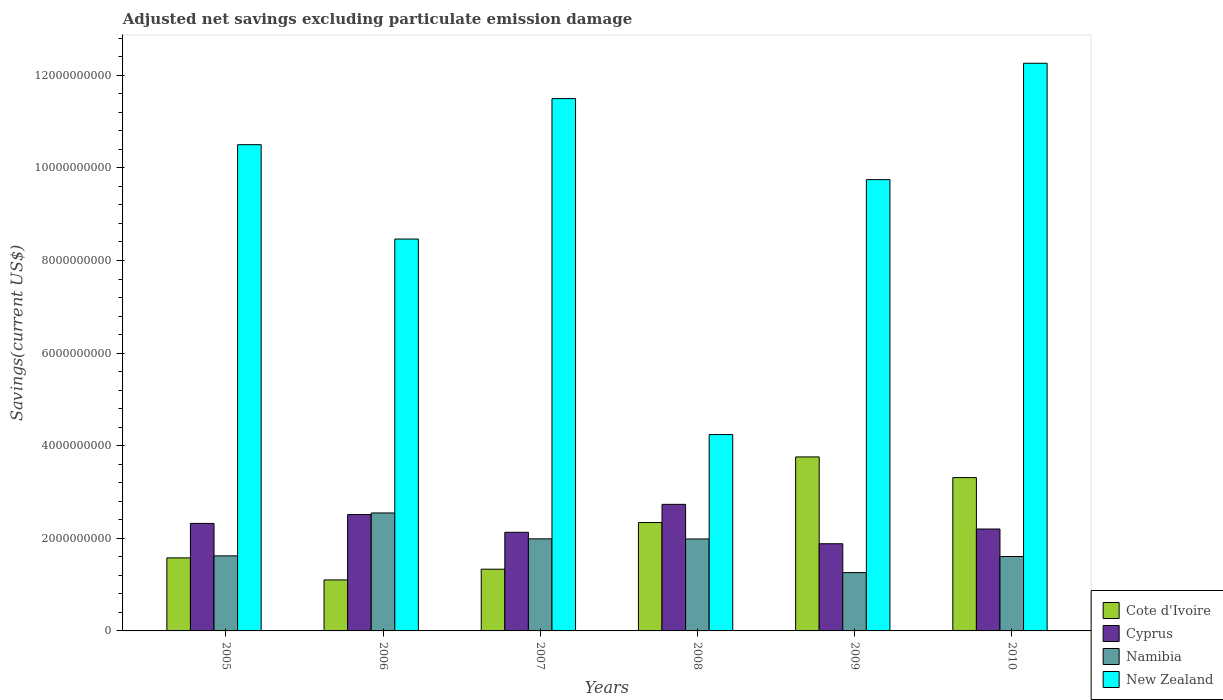Are the number of bars per tick equal to the number of legend labels?
Offer a very short reply. Yes. Are the number of bars on each tick of the X-axis equal?
Ensure brevity in your answer.  Yes. How many bars are there on the 6th tick from the left?
Provide a succinct answer. 4. How many bars are there on the 2nd tick from the right?
Your response must be concise. 4. What is the adjusted net savings in Namibia in 2009?
Make the answer very short. 1.26e+09. Across all years, what is the maximum adjusted net savings in Cyprus?
Keep it short and to the point. 2.73e+09. Across all years, what is the minimum adjusted net savings in Namibia?
Your answer should be compact. 1.26e+09. In which year was the adjusted net savings in Cote d'Ivoire maximum?
Provide a succinct answer. 2009. What is the total adjusted net savings in Cyprus in the graph?
Provide a succinct answer. 1.38e+1. What is the difference between the adjusted net savings in Cote d'Ivoire in 2005 and that in 2006?
Your answer should be compact. 4.76e+08. What is the difference between the adjusted net savings in New Zealand in 2008 and the adjusted net savings in Namibia in 2005?
Give a very brief answer. 2.62e+09. What is the average adjusted net savings in New Zealand per year?
Provide a short and direct response. 9.45e+09. In the year 2006, what is the difference between the adjusted net savings in Cote d'Ivoire and adjusted net savings in Cyprus?
Give a very brief answer. -1.41e+09. What is the ratio of the adjusted net savings in New Zealand in 2005 to that in 2006?
Your answer should be very brief. 1.24. Is the adjusted net savings in Cyprus in 2007 less than that in 2008?
Give a very brief answer. Yes. Is the difference between the adjusted net savings in Cote d'Ivoire in 2006 and 2009 greater than the difference between the adjusted net savings in Cyprus in 2006 and 2009?
Give a very brief answer. No. What is the difference between the highest and the second highest adjusted net savings in Cyprus?
Keep it short and to the point. 2.20e+08. What is the difference between the highest and the lowest adjusted net savings in New Zealand?
Your answer should be compact. 8.02e+09. Is the sum of the adjusted net savings in Cote d'Ivoire in 2009 and 2010 greater than the maximum adjusted net savings in Cyprus across all years?
Give a very brief answer. Yes. What does the 3rd bar from the left in 2010 represents?
Give a very brief answer. Namibia. What does the 1st bar from the right in 2008 represents?
Offer a very short reply. New Zealand. Is it the case that in every year, the sum of the adjusted net savings in Namibia and adjusted net savings in Cote d'Ivoire is greater than the adjusted net savings in Cyprus?
Offer a terse response. Yes. How many bars are there?
Keep it short and to the point. 24. Does the graph contain grids?
Give a very brief answer. No. Where does the legend appear in the graph?
Your response must be concise. Bottom right. What is the title of the graph?
Make the answer very short. Adjusted net savings excluding particulate emission damage. What is the label or title of the Y-axis?
Your answer should be compact. Savings(current US$). What is the Savings(current US$) of Cote d'Ivoire in 2005?
Offer a very short reply. 1.58e+09. What is the Savings(current US$) of Cyprus in 2005?
Offer a very short reply. 2.32e+09. What is the Savings(current US$) in Namibia in 2005?
Offer a very short reply. 1.62e+09. What is the Savings(current US$) of New Zealand in 2005?
Your response must be concise. 1.05e+1. What is the Savings(current US$) in Cote d'Ivoire in 2006?
Keep it short and to the point. 1.10e+09. What is the Savings(current US$) of Cyprus in 2006?
Ensure brevity in your answer.  2.51e+09. What is the Savings(current US$) in Namibia in 2006?
Your response must be concise. 2.55e+09. What is the Savings(current US$) in New Zealand in 2006?
Your response must be concise. 8.46e+09. What is the Savings(current US$) in Cote d'Ivoire in 2007?
Give a very brief answer. 1.33e+09. What is the Savings(current US$) in Cyprus in 2007?
Keep it short and to the point. 2.13e+09. What is the Savings(current US$) of Namibia in 2007?
Offer a terse response. 1.99e+09. What is the Savings(current US$) in New Zealand in 2007?
Your answer should be very brief. 1.15e+1. What is the Savings(current US$) of Cote d'Ivoire in 2008?
Give a very brief answer. 2.34e+09. What is the Savings(current US$) in Cyprus in 2008?
Keep it short and to the point. 2.73e+09. What is the Savings(current US$) in Namibia in 2008?
Provide a short and direct response. 1.99e+09. What is the Savings(current US$) in New Zealand in 2008?
Ensure brevity in your answer.  4.24e+09. What is the Savings(current US$) in Cote d'Ivoire in 2009?
Give a very brief answer. 3.76e+09. What is the Savings(current US$) in Cyprus in 2009?
Provide a succinct answer. 1.88e+09. What is the Savings(current US$) of Namibia in 2009?
Offer a terse response. 1.26e+09. What is the Savings(current US$) of New Zealand in 2009?
Provide a succinct answer. 9.75e+09. What is the Savings(current US$) in Cote d'Ivoire in 2010?
Provide a succinct answer. 3.31e+09. What is the Savings(current US$) in Cyprus in 2010?
Keep it short and to the point. 2.20e+09. What is the Savings(current US$) of Namibia in 2010?
Your response must be concise. 1.61e+09. What is the Savings(current US$) in New Zealand in 2010?
Your answer should be very brief. 1.23e+1. Across all years, what is the maximum Savings(current US$) in Cote d'Ivoire?
Provide a short and direct response. 3.76e+09. Across all years, what is the maximum Savings(current US$) of Cyprus?
Ensure brevity in your answer.  2.73e+09. Across all years, what is the maximum Savings(current US$) of Namibia?
Your answer should be very brief. 2.55e+09. Across all years, what is the maximum Savings(current US$) of New Zealand?
Give a very brief answer. 1.23e+1. Across all years, what is the minimum Savings(current US$) of Cote d'Ivoire?
Your answer should be very brief. 1.10e+09. Across all years, what is the minimum Savings(current US$) of Cyprus?
Your response must be concise. 1.88e+09. Across all years, what is the minimum Savings(current US$) in Namibia?
Your response must be concise. 1.26e+09. Across all years, what is the minimum Savings(current US$) in New Zealand?
Ensure brevity in your answer.  4.24e+09. What is the total Savings(current US$) of Cote d'Ivoire in the graph?
Your answer should be very brief. 1.34e+1. What is the total Savings(current US$) in Cyprus in the graph?
Offer a very short reply. 1.38e+1. What is the total Savings(current US$) of Namibia in the graph?
Keep it short and to the point. 1.10e+1. What is the total Savings(current US$) in New Zealand in the graph?
Make the answer very short. 5.67e+1. What is the difference between the Savings(current US$) in Cote d'Ivoire in 2005 and that in 2006?
Provide a succinct answer. 4.76e+08. What is the difference between the Savings(current US$) of Cyprus in 2005 and that in 2006?
Your response must be concise. -1.91e+08. What is the difference between the Savings(current US$) in Namibia in 2005 and that in 2006?
Your answer should be compact. -9.27e+08. What is the difference between the Savings(current US$) in New Zealand in 2005 and that in 2006?
Make the answer very short. 2.04e+09. What is the difference between the Savings(current US$) of Cote d'Ivoire in 2005 and that in 2007?
Ensure brevity in your answer.  2.44e+08. What is the difference between the Savings(current US$) of Cyprus in 2005 and that in 2007?
Provide a short and direct response. 1.92e+08. What is the difference between the Savings(current US$) in Namibia in 2005 and that in 2007?
Ensure brevity in your answer.  -3.68e+08. What is the difference between the Savings(current US$) of New Zealand in 2005 and that in 2007?
Make the answer very short. -9.95e+08. What is the difference between the Savings(current US$) of Cote d'Ivoire in 2005 and that in 2008?
Provide a succinct answer. -7.64e+08. What is the difference between the Savings(current US$) of Cyprus in 2005 and that in 2008?
Offer a terse response. -4.12e+08. What is the difference between the Savings(current US$) of Namibia in 2005 and that in 2008?
Provide a short and direct response. -3.65e+08. What is the difference between the Savings(current US$) of New Zealand in 2005 and that in 2008?
Ensure brevity in your answer.  6.26e+09. What is the difference between the Savings(current US$) in Cote d'Ivoire in 2005 and that in 2009?
Provide a succinct answer. -2.18e+09. What is the difference between the Savings(current US$) of Cyprus in 2005 and that in 2009?
Your response must be concise. 4.39e+08. What is the difference between the Savings(current US$) in Namibia in 2005 and that in 2009?
Provide a short and direct response. 3.61e+08. What is the difference between the Savings(current US$) of New Zealand in 2005 and that in 2009?
Offer a very short reply. 7.55e+08. What is the difference between the Savings(current US$) in Cote d'Ivoire in 2005 and that in 2010?
Provide a short and direct response. -1.73e+09. What is the difference between the Savings(current US$) of Cyprus in 2005 and that in 2010?
Your response must be concise. 1.21e+08. What is the difference between the Savings(current US$) in Namibia in 2005 and that in 2010?
Provide a short and direct response. 1.40e+07. What is the difference between the Savings(current US$) of New Zealand in 2005 and that in 2010?
Your answer should be very brief. -1.76e+09. What is the difference between the Savings(current US$) in Cote d'Ivoire in 2006 and that in 2007?
Keep it short and to the point. -2.32e+08. What is the difference between the Savings(current US$) in Cyprus in 2006 and that in 2007?
Your answer should be compact. 3.83e+08. What is the difference between the Savings(current US$) in Namibia in 2006 and that in 2007?
Provide a short and direct response. 5.59e+08. What is the difference between the Savings(current US$) of New Zealand in 2006 and that in 2007?
Make the answer very short. -3.03e+09. What is the difference between the Savings(current US$) of Cote d'Ivoire in 2006 and that in 2008?
Provide a succinct answer. -1.24e+09. What is the difference between the Savings(current US$) of Cyprus in 2006 and that in 2008?
Ensure brevity in your answer.  -2.20e+08. What is the difference between the Savings(current US$) in Namibia in 2006 and that in 2008?
Offer a terse response. 5.61e+08. What is the difference between the Savings(current US$) of New Zealand in 2006 and that in 2008?
Offer a very short reply. 4.22e+09. What is the difference between the Savings(current US$) of Cote d'Ivoire in 2006 and that in 2009?
Ensure brevity in your answer.  -2.66e+09. What is the difference between the Savings(current US$) of Cyprus in 2006 and that in 2009?
Make the answer very short. 6.30e+08. What is the difference between the Savings(current US$) of Namibia in 2006 and that in 2009?
Offer a very short reply. 1.29e+09. What is the difference between the Savings(current US$) of New Zealand in 2006 and that in 2009?
Ensure brevity in your answer.  -1.28e+09. What is the difference between the Savings(current US$) in Cote d'Ivoire in 2006 and that in 2010?
Offer a terse response. -2.21e+09. What is the difference between the Savings(current US$) of Cyprus in 2006 and that in 2010?
Make the answer very short. 3.12e+08. What is the difference between the Savings(current US$) of Namibia in 2006 and that in 2010?
Your answer should be very brief. 9.41e+08. What is the difference between the Savings(current US$) of New Zealand in 2006 and that in 2010?
Your response must be concise. -3.80e+09. What is the difference between the Savings(current US$) of Cote d'Ivoire in 2007 and that in 2008?
Ensure brevity in your answer.  -1.01e+09. What is the difference between the Savings(current US$) in Cyprus in 2007 and that in 2008?
Ensure brevity in your answer.  -6.04e+08. What is the difference between the Savings(current US$) of Namibia in 2007 and that in 2008?
Provide a succinct answer. 2.53e+06. What is the difference between the Savings(current US$) in New Zealand in 2007 and that in 2008?
Offer a very short reply. 7.26e+09. What is the difference between the Savings(current US$) of Cote d'Ivoire in 2007 and that in 2009?
Ensure brevity in your answer.  -2.42e+09. What is the difference between the Savings(current US$) of Cyprus in 2007 and that in 2009?
Keep it short and to the point. 2.47e+08. What is the difference between the Savings(current US$) in Namibia in 2007 and that in 2009?
Provide a succinct answer. 7.29e+08. What is the difference between the Savings(current US$) of New Zealand in 2007 and that in 2009?
Make the answer very short. 1.75e+09. What is the difference between the Savings(current US$) in Cote d'Ivoire in 2007 and that in 2010?
Provide a short and direct response. -1.98e+09. What is the difference between the Savings(current US$) of Cyprus in 2007 and that in 2010?
Provide a succinct answer. -7.11e+07. What is the difference between the Savings(current US$) of Namibia in 2007 and that in 2010?
Your response must be concise. 3.82e+08. What is the difference between the Savings(current US$) of New Zealand in 2007 and that in 2010?
Provide a succinct answer. -7.63e+08. What is the difference between the Savings(current US$) in Cote d'Ivoire in 2008 and that in 2009?
Your answer should be very brief. -1.42e+09. What is the difference between the Savings(current US$) in Cyprus in 2008 and that in 2009?
Provide a short and direct response. 8.51e+08. What is the difference between the Savings(current US$) of Namibia in 2008 and that in 2009?
Offer a terse response. 7.27e+08. What is the difference between the Savings(current US$) in New Zealand in 2008 and that in 2009?
Provide a short and direct response. -5.51e+09. What is the difference between the Savings(current US$) of Cote d'Ivoire in 2008 and that in 2010?
Offer a very short reply. -9.71e+08. What is the difference between the Savings(current US$) in Cyprus in 2008 and that in 2010?
Give a very brief answer. 5.33e+08. What is the difference between the Savings(current US$) in Namibia in 2008 and that in 2010?
Provide a short and direct response. 3.79e+08. What is the difference between the Savings(current US$) of New Zealand in 2008 and that in 2010?
Offer a very short reply. -8.02e+09. What is the difference between the Savings(current US$) in Cote d'Ivoire in 2009 and that in 2010?
Ensure brevity in your answer.  4.46e+08. What is the difference between the Savings(current US$) of Cyprus in 2009 and that in 2010?
Keep it short and to the point. -3.18e+08. What is the difference between the Savings(current US$) of Namibia in 2009 and that in 2010?
Your answer should be very brief. -3.47e+08. What is the difference between the Savings(current US$) in New Zealand in 2009 and that in 2010?
Provide a succinct answer. -2.51e+09. What is the difference between the Savings(current US$) of Cote d'Ivoire in 2005 and the Savings(current US$) of Cyprus in 2006?
Make the answer very short. -9.36e+08. What is the difference between the Savings(current US$) in Cote d'Ivoire in 2005 and the Savings(current US$) in Namibia in 2006?
Keep it short and to the point. -9.70e+08. What is the difference between the Savings(current US$) in Cote d'Ivoire in 2005 and the Savings(current US$) in New Zealand in 2006?
Give a very brief answer. -6.89e+09. What is the difference between the Savings(current US$) in Cyprus in 2005 and the Savings(current US$) in Namibia in 2006?
Your answer should be very brief. -2.26e+08. What is the difference between the Savings(current US$) in Cyprus in 2005 and the Savings(current US$) in New Zealand in 2006?
Provide a succinct answer. -6.14e+09. What is the difference between the Savings(current US$) in Namibia in 2005 and the Savings(current US$) in New Zealand in 2006?
Give a very brief answer. -6.84e+09. What is the difference between the Savings(current US$) of Cote d'Ivoire in 2005 and the Savings(current US$) of Cyprus in 2007?
Offer a terse response. -5.53e+08. What is the difference between the Savings(current US$) in Cote d'Ivoire in 2005 and the Savings(current US$) in Namibia in 2007?
Provide a short and direct response. -4.11e+08. What is the difference between the Savings(current US$) of Cote d'Ivoire in 2005 and the Savings(current US$) of New Zealand in 2007?
Provide a short and direct response. -9.92e+09. What is the difference between the Savings(current US$) in Cyprus in 2005 and the Savings(current US$) in Namibia in 2007?
Provide a succinct answer. 3.33e+08. What is the difference between the Savings(current US$) of Cyprus in 2005 and the Savings(current US$) of New Zealand in 2007?
Provide a succinct answer. -9.18e+09. What is the difference between the Savings(current US$) of Namibia in 2005 and the Savings(current US$) of New Zealand in 2007?
Offer a very short reply. -9.88e+09. What is the difference between the Savings(current US$) of Cote d'Ivoire in 2005 and the Savings(current US$) of Cyprus in 2008?
Provide a short and direct response. -1.16e+09. What is the difference between the Savings(current US$) in Cote d'Ivoire in 2005 and the Savings(current US$) in Namibia in 2008?
Give a very brief answer. -4.09e+08. What is the difference between the Savings(current US$) of Cote d'Ivoire in 2005 and the Savings(current US$) of New Zealand in 2008?
Provide a short and direct response. -2.66e+09. What is the difference between the Savings(current US$) of Cyprus in 2005 and the Savings(current US$) of Namibia in 2008?
Your answer should be compact. 3.36e+08. What is the difference between the Savings(current US$) in Cyprus in 2005 and the Savings(current US$) in New Zealand in 2008?
Offer a very short reply. -1.92e+09. What is the difference between the Savings(current US$) of Namibia in 2005 and the Savings(current US$) of New Zealand in 2008?
Ensure brevity in your answer.  -2.62e+09. What is the difference between the Savings(current US$) of Cote d'Ivoire in 2005 and the Savings(current US$) of Cyprus in 2009?
Offer a very short reply. -3.06e+08. What is the difference between the Savings(current US$) of Cote d'Ivoire in 2005 and the Savings(current US$) of Namibia in 2009?
Your response must be concise. 3.18e+08. What is the difference between the Savings(current US$) of Cote d'Ivoire in 2005 and the Savings(current US$) of New Zealand in 2009?
Give a very brief answer. -8.17e+09. What is the difference between the Savings(current US$) in Cyprus in 2005 and the Savings(current US$) in Namibia in 2009?
Your response must be concise. 1.06e+09. What is the difference between the Savings(current US$) in Cyprus in 2005 and the Savings(current US$) in New Zealand in 2009?
Make the answer very short. -7.43e+09. What is the difference between the Savings(current US$) of Namibia in 2005 and the Savings(current US$) of New Zealand in 2009?
Ensure brevity in your answer.  -8.13e+09. What is the difference between the Savings(current US$) of Cote d'Ivoire in 2005 and the Savings(current US$) of Cyprus in 2010?
Provide a short and direct response. -6.24e+08. What is the difference between the Savings(current US$) of Cote d'Ivoire in 2005 and the Savings(current US$) of Namibia in 2010?
Provide a succinct answer. -2.97e+07. What is the difference between the Savings(current US$) in Cote d'Ivoire in 2005 and the Savings(current US$) in New Zealand in 2010?
Offer a very short reply. -1.07e+1. What is the difference between the Savings(current US$) in Cyprus in 2005 and the Savings(current US$) in Namibia in 2010?
Your response must be concise. 7.15e+08. What is the difference between the Savings(current US$) in Cyprus in 2005 and the Savings(current US$) in New Zealand in 2010?
Your response must be concise. -9.94e+09. What is the difference between the Savings(current US$) in Namibia in 2005 and the Savings(current US$) in New Zealand in 2010?
Provide a short and direct response. -1.06e+1. What is the difference between the Savings(current US$) in Cote d'Ivoire in 2006 and the Savings(current US$) in Cyprus in 2007?
Give a very brief answer. -1.03e+09. What is the difference between the Savings(current US$) in Cote d'Ivoire in 2006 and the Savings(current US$) in Namibia in 2007?
Offer a terse response. -8.87e+08. What is the difference between the Savings(current US$) of Cote d'Ivoire in 2006 and the Savings(current US$) of New Zealand in 2007?
Give a very brief answer. -1.04e+1. What is the difference between the Savings(current US$) of Cyprus in 2006 and the Savings(current US$) of Namibia in 2007?
Provide a succinct answer. 5.25e+08. What is the difference between the Savings(current US$) in Cyprus in 2006 and the Savings(current US$) in New Zealand in 2007?
Ensure brevity in your answer.  -8.98e+09. What is the difference between the Savings(current US$) of Namibia in 2006 and the Savings(current US$) of New Zealand in 2007?
Provide a succinct answer. -8.95e+09. What is the difference between the Savings(current US$) of Cote d'Ivoire in 2006 and the Savings(current US$) of Cyprus in 2008?
Offer a very short reply. -1.63e+09. What is the difference between the Savings(current US$) in Cote d'Ivoire in 2006 and the Savings(current US$) in Namibia in 2008?
Ensure brevity in your answer.  -8.85e+08. What is the difference between the Savings(current US$) of Cote d'Ivoire in 2006 and the Savings(current US$) of New Zealand in 2008?
Provide a short and direct response. -3.14e+09. What is the difference between the Savings(current US$) in Cyprus in 2006 and the Savings(current US$) in Namibia in 2008?
Offer a very short reply. 5.27e+08. What is the difference between the Savings(current US$) of Cyprus in 2006 and the Savings(current US$) of New Zealand in 2008?
Offer a very short reply. -1.73e+09. What is the difference between the Savings(current US$) in Namibia in 2006 and the Savings(current US$) in New Zealand in 2008?
Keep it short and to the point. -1.69e+09. What is the difference between the Savings(current US$) in Cote d'Ivoire in 2006 and the Savings(current US$) in Cyprus in 2009?
Provide a succinct answer. -7.81e+08. What is the difference between the Savings(current US$) in Cote d'Ivoire in 2006 and the Savings(current US$) in Namibia in 2009?
Make the answer very short. -1.58e+08. What is the difference between the Savings(current US$) of Cote d'Ivoire in 2006 and the Savings(current US$) of New Zealand in 2009?
Ensure brevity in your answer.  -8.65e+09. What is the difference between the Savings(current US$) in Cyprus in 2006 and the Savings(current US$) in Namibia in 2009?
Make the answer very short. 1.25e+09. What is the difference between the Savings(current US$) of Cyprus in 2006 and the Savings(current US$) of New Zealand in 2009?
Offer a very short reply. -7.23e+09. What is the difference between the Savings(current US$) in Namibia in 2006 and the Savings(current US$) in New Zealand in 2009?
Keep it short and to the point. -7.20e+09. What is the difference between the Savings(current US$) in Cote d'Ivoire in 2006 and the Savings(current US$) in Cyprus in 2010?
Offer a very short reply. -1.10e+09. What is the difference between the Savings(current US$) in Cote d'Ivoire in 2006 and the Savings(current US$) in Namibia in 2010?
Keep it short and to the point. -5.05e+08. What is the difference between the Savings(current US$) in Cote d'Ivoire in 2006 and the Savings(current US$) in New Zealand in 2010?
Provide a short and direct response. -1.12e+1. What is the difference between the Savings(current US$) in Cyprus in 2006 and the Savings(current US$) in Namibia in 2010?
Offer a terse response. 9.06e+08. What is the difference between the Savings(current US$) in Cyprus in 2006 and the Savings(current US$) in New Zealand in 2010?
Give a very brief answer. -9.75e+09. What is the difference between the Savings(current US$) in Namibia in 2006 and the Savings(current US$) in New Zealand in 2010?
Your answer should be very brief. -9.71e+09. What is the difference between the Savings(current US$) of Cote d'Ivoire in 2007 and the Savings(current US$) of Cyprus in 2008?
Ensure brevity in your answer.  -1.40e+09. What is the difference between the Savings(current US$) in Cote d'Ivoire in 2007 and the Savings(current US$) in Namibia in 2008?
Make the answer very short. -6.53e+08. What is the difference between the Savings(current US$) in Cote d'Ivoire in 2007 and the Savings(current US$) in New Zealand in 2008?
Ensure brevity in your answer.  -2.91e+09. What is the difference between the Savings(current US$) in Cyprus in 2007 and the Savings(current US$) in Namibia in 2008?
Offer a terse response. 1.44e+08. What is the difference between the Savings(current US$) of Cyprus in 2007 and the Savings(current US$) of New Zealand in 2008?
Your answer should be very brief. -2.11e+09. What is the difference between the Savings(current US$) in Namibia in 2007 and the Savings(current US$) in New Zealand in 2008?
Keep it short and to the point. -2.25e+09. What is the difference between the Savings(current US$) of Cote d'Ivoire in 2007 and the Savings(current US$) of Cyprus in 2009?
Provide a succinct answer. -5.50e+08. What is the difference between the Savings(current US$) in Cote d'Ivoire in 2007 and the Savings(current US$) in Namibia in 2009?
Your answer should be very brief. 7.36e+07. What is the difference between the Savings(current US$) of Cote d'Ivoire in 2007 and the Savings(current US$) of New Zealand in 2009?
Provide a succinct answer. -8.41e+09. What is the difference between the Savings(current US$) of Cyprus in 2007 and the Savings(current US$) of Namibia in 2009?
Offer a very short reply. 8.70e+08. What is the difference between the Savings(current US$) in Cyprus in 2007 and the Savings(current US$) in New Zealand in 2009?
Your answer should be very brief. -7.62e+09. What is the difference between the Savings(current US$) in Namibia in 2007 and the Savings(current US$) in New Zealand in 2009?
Make the answer very short. -7.76e+09. What is the difference between the Savings(current US$) of Cote d'Ivoire in 2007 and the Savings(current US$) of Cyprus in 2010?
Provide a succinct answer. -8.68e+08. What is the difference between the Savings(current US$) in Cote d'Ivoire in 2007 and the Savings(current US$) in Namibia in 2010?
Ensure brevity in your answer.  -2.74e+08. What is the difference between the Savings(current US$) of Cote d'Ivoire in 2007 and the Savings(current US$) of New Zealand in 2010?
Provide a succinct answer. -1.09e+1. What is the difference between the Savings(current US$) in Cyprus in 2007 and the Savings(current US$) in Namibia in 2010?
Give a very brief answer. 5.23e+08. What is the difference between the Savings(current US$) of Cyprus in 2007 and the Savings(current US$) of New Zealand in 2010?
Provide a short and direct response. -1.01e+1. What is the difference between the Savings(current US$) in Namibia in 2007 and the Savings(current US$) in New Zealand in 2010?
Your response must be concise. -1.03e+1. What is the difference between the Savings(current US$) of Cote d'Ivoire in 2008 and the Savings(current US$) of Cyprus in 2009?
Make the answer very short. 4.58e+08. What is the difference between the Savings(current US$) in Cote d'Ivoire in 2008 and the Savings(current US$) in Namibia in 2009?
Your answer should be compact. 1.08e+09. What is the difference between the Savings(current US$) in Cote d'Ivoire in 2008 and the Savings(current US$) in New Zealand in 2009?
Ensure brevity in your answer.  -7.41e+09. What is the difference between the Savings(current US$) in Cyprus in 2008 and the Savings(current US$) in Namibia in 2009?
Your answer should be compact. 1.47e+09. What is the difference between the Savings(current US$) of Cyprus in 2008 and the Savings(current US$) of New Zealand in 2009?
Keep it short and to the point. -7.01e+09. What is the difference between the Savings(current US$) in Namibia in 2008 and the Savings(current US$) in New Zealand in 2009?
Your response must be concise. -7.76e+09. What is the difference between the Savings(current US$) of Cote d'Ivoire in 2008 and the Savings(current US$) of Cyprus in 2010?
Your response must be concise. 1.40e+08. What is the difference between the Savings(current US$) in Cote d'Ivoire in 2008 and the Savings(current US$) in Namibia in 2010?
Keep it short and to the point. 7.34e+08. What is the difference between the Savings(current US$) in Cote d'Ivoire in 2008 and the Savings(current US$) in New Zealand in 2010?
Your answer should be compact. -9.92e+09. What is the difference between the Savings(current US$) in Cyprus in 2008 and the Savings(current US$) in Namibia in 2010?
Your answer should be very brief. 1.13e+09. What is the difference between the Savings(current US$) of Cyprus in 2008 and the Savings(current US$) of New Zealand in 2010?
Make the answer very short. -9.53e+09. What is the difference between the Savings(current US$) in Namibia in 2008 and the Savings(current US$) in New Zealand in 2010?
Your response must be concise. -1.03e+1. What is the difference between the Savings(current US$) in Cote d'Ivoire in 2009 and the Savings(current US$) in Cyprus in 2010?
Make the answer very short. 1.56e+09. What is the difference between the Savings(current US$) of Cote d'Ivoire in 2009 and the Savings(current US$) of Namibia in 2010?
Provide a short and direct response. 2.15e+09. What is the difference between the Savings(current US$) of Cote d'Ivoire in 2009 and the Savings(current US$) of New Zealand in 2010?
Your answer should be very brief. -8.50e+09. What is the difference between the Savings(current US$) in Cyprus in 2009 and the Savings(current US$) in Namibia in 2010?
Give a very brief answer. 2.76e+08. What is the difference between the Savings(current US$) in Cyprus in 2009 and the Savings(current US$) in New Zealand in 2010?
Keep it short and to the point. -1.04e+1. What is the difference between the Savings(current US$) in Namibia in 2009 and the Savings(current US$) in New Zealand in 2010?
Your response must be concise. -1.10e+1. What is the average Savings(current US$) of Cote d'Ivoire per year?
Your answer should be compact. 2.24e+09. What is the average Savings(current US$) of Cyprus per year?
Offer a terse response. 2.30e+09. What is the average Savings(current US$) of Namibia per year?
Make the answer very short. 1.84e+09. What is the average Savings(current US$) in New Zealand per year?
Provide a succinct answer. 9.45e+09. In the year 2005, what is the difference between the Savings(current US$) of Cote d'Ivoire and Savings(current US$) of Cyprus?
Give a very brief answer. -7.45e+08. In the year 2005, what is the difference between the Savings(current US$) of Cote d'Ivoire and Savings(current US$) of Namibia?
Keep it short and to the point. -4.37e+07. In the year 2005, what is the difference between the Savings(current US$) of Cote d'Ivoire and Savings(current US$) of New Zealand?
Give a very brief answer. -8.92e+09. In the year 2005, what is the difference between the Savings(current US$) in Cyprus and Savings(current US$) in Namibia?
Ensure brevity in your answer.  7.01e+08. In the year 2005, what is the difference between the Savings(current US$) in Cyprus and Savings(current US$) in New Zealand?
Offer a terse response. -8.18e+09. In the year 2005, what is the difference between the Savings(current US$) of Namibia and Savings(current US$) of New Zealand?
Make the answer very short. -8.88e+09. In the year 2006, what is the difference between the Savings(current US$) in Cote d'Ivoire and Savings(current US$) in Cyprus?
Your response must be concise. -1.41e+09. In the year 2006, what is the difference between the Savings(current US$) in Cote d'Ivoire and Savings(current US$) in Namibia?
Provide a succinct answer. -1.45e+09. In the year 2006, what is the difference between the Savings(current US$) of Cote d'Ivoire and Savings(current US$) of New Zealand?
Make the answer very short. -7.36e+09. In the year 2006, what is the difference between the Savings(current US$) of Cyprus and Savings(current US$) of Namibia?
Provide a succinct answer. -3.44e+07. In the year 2006, what is the difference between the Savings(current US$) of Cyprus and Savings(current US$) of New Zealand?
Keep it short and to the point. -5.95e+09. In the year 2006, what is the difference between the Savings(current US$) in Namibia and Savings(current US$) in New Zealand?
Your answer should be very brief. -5.92e+09. In the year 2007, what is the difference between the Savings(current US$) in Cote d'Ivoire and Savings(current US$) in Cyprus?
Give a very brief answer. -7.97e+08. In the year 2007, what is the difference between the Savings(current US$) in Cote d'Ivoire and Savings(current US$) in Namibia?
Offer a very short reply. -6.56e+08. In the year 2007, what is the difference between the Savings(current US$) of Cote d'Ivoire and Savings(current US$) of New Zealand?
Give a very brief answer. -1.02e+1. In the year 2007, what is the difference between the Savings(current US$) in Cyprus and Savings(current US$) in Namibia?
Offer a very short reply. 1.41e+08. In the year 2007, what is the difference between the Savings(current US$) in Cyprus and Savings(current US$) in New Zealand?
Provide a short and direct response. -9.37e+09. In the year 2007, what is the difference between the Savings(current US$) in Namibia and Savings(current US$) in New Zealand?
Your answer should be compact. -9.51e+09. In the year 2008, what is the difference between the Savings(current US$) of Cote d'Ivoire and Savings(current US$) of Cyprus?
Keep it short and to the point. -3.93e+08. In the year 2008, what is the difference between the Savings(current US$) in Cote d'Ivoire and Savings(current US$) in Namibia?
Provide a succinct answer. 3.55e+08. In the year 2008, what is the difference between the Savings(current US$) in Cote d'Ivoire and Savings(current US$) in New Zealand?
Keep it short and to the point. -1.90e+09. In the year 2008, what is the difference between the Savings(current US$) of Cyprus and Savings(current US$) of Namibia?
Offer a very short reply. 7.47e+08. In the year 2008, what is the difference between the Savings(current US$) of Cyprus and Savings(current US$) of New Zealand?
Provide a short and direct response. -1.51e+09. In the year 2008, what is the difference between the Savings(current US$) of Namibia and Savings(current US$) of New Zealand?
Your answer should be very brief. -2.25e+09. In the year 2009, what is the difference between the Savings(current US$) in Cote d'Ivoire and Savings(current US$) in Cyprus?
Give a very brief answer. 1.88e+09. In the year 2009, what is the difference between the Savings(current US$) of Cote d'Ivoire and Savings(current US$) of Namibia?
Give a very brief answer. 2.50e+09. In the year 2009, what is the difference between the Savings(current US$) of Cote d'Ivoire and Savings(current US$) of New Zealand?
Provide a short and direct response. -5.99e+09. In the year 2009, what is the difference between the Savings(current US$) of Cyprus and Savings(current US$) of Namibia?
Make the answer very short. 6.23e+08. In the year 2009, what is the difference between the Savings(current US$) in Cyprus and Savings(current US$) in New Zealand?
Your answer should be very brief. -7.86e+09. In the year 2009, what is the difference between the Savings(current US$) in Namibia and Savings(current US$) in New Zealand?
Provide a succinct answer. -8.49e+09. In the year 2010, what is the difference between the Savings(current US$) in Cote d'Ivoire and Savings(current US$) in Cyprus?
Your response must be concise. 1.11e+09. In the year 2010, what is the difference between the Savings(current US$) in Cote d'Ivoire and Savings(current US$) in Namibia?
Provide a succinct answer. 1.70e+09. In the year 2010, what is the difference between the Savings(current US$) of Cote d'Ivoire and Savings(current US$) of New Zealand?
Provide a short and direct response. -8.95e+09. In the year 2010, what is the difference between the Savings(current US$) of Cyprus and Savings(current US$) of Namibia?
Provide a succinct answer. 5.94e+08. In the year 2010, what is the difference between the Savings(current US$) of Cyprus and Savings(current US$) of New Zealand?
Provide a short and direct response. -1.01e+1. In the year 2010, what is the difference between the Savings(current US$) of Namibia and Savings(current US$) of New Zealand?
Provide a succinct answer. -1.07e+1. What is the ratio of the Savings(current US$) of Cote d'Ivoire in 2005 to that in 2006?
Your answer should be compact. 1.43. What is the ratio of the Savings(current US$) of Cyprus in 2005 to that in 2006?
Ensure brevity in your answer.  0.92. What is the ratio of the Savings(current US$) of Namibia in 2005 to that in 2006?
Offer a very short reply. 0.64. What is the ratio of the Savings(current US$) of New Zealand in 2005 to that in 2006?
Ensure brevity in your answer.  1.24. What is the ratio of the Savings(current US$) of Cote d'Ivoire in 2005 to that in 2007?
Make the answer very short. 1.18. What is the ratio of the Savings(current US$) of Cyprus in 2005 to that in 2007?
Your response must be concise. 1.09. What is the ratio of the Savings(current US$) of Namibia in 2005 to that in 2007?
Give a very brief answer. 0.82. What is the ratio of the Savings(current US$) in New Zealand in 2005 to that in 2007?
Offer a terse response. 0.91. What is the ratio of the Savings(current US$) in Cote d'Ivoire in 2005 to that in 2008?
Ensure brevity in your answer.  0.67. What is the ratio of the Savings(current US$) of Cyprus in 2005 to that in 2008?
Ensure brevity in your answer.  0.85. What is the ratio of the Savings(current US$) of Namibia in 2005 to that in 2008?
Provide a succinct answer. 0.82. What is the ratio of the Savings(current US$) of New Zealand in 2005 to that in 2008?
Your answer should be compact. 2.48. What is the ratio of the Savings(current US$) of Cote d'Ivoire in 2005 to that in 2009?
Your answer should be compact. 0.42. What is the ratio of the Savings(current US$) of Cyprus in 2005 to that in 2009?
Your response must be concise. 1.23. What is the ratio of the Savings(current US$) of Namibia in 2005 to that in 2009?
Your answer should be very brief. 1.29. What is the ratio of the Savings(current US$) in New Zealand in 2005 to that in 2009?
Keep it short and to the point. 1.08. What is the ratio of the Savings(current US$) in Cote d'Ivoire in 2005 to that in 2010?
Offer a very short reply. 0.48. What is the ratio of the Savings(current US$) of Cyprus in 2005 to that in 2010?
Provide a succinct answer. 1.05. What is the ratio of the Savings(current US$) in Namibia in 2005 to that in 2010?
Your answer should be compact. 1.01. What is the ratio of the Savings(current US$) of New Zealand in 2005 to that in 2010?
Provide a succinct answer. 0.86. What is the ratio of the Savings(current US$) in Cote d'Ivoire in 2006 to that in 2007?
Provide a succinct answer. 0.83. What is the ratio of the Savings(current US$) in Cyprus in 2006 to that in 2007?
Your answer should be very brief. 1.18. What is the ratio of the Savings(current US$) in Namibia in 2006 to that in 2007?
Provide a succinct answer. 1.28. What is the ratio of the Savings(current US$) in New Zealand in 2006 to that in 2007?
Your answer should be compact. 0.74. What is the ratio of the Savings(current US$) of Cote d'Ivoire in 2006 to that in 2008?
Provide a succinct answer. 0.47. What is the ratio of the Savings(current US$) in Cyprus in 2006 to that in 2008?
Ensure brevity in your answer.  0.92. What is the ratio of the Savings(current US$) of Namibia in 2006 to that in 2008?
Keep it short and to the point. 1.28. What is the ratio of the Savings(current US$) in New Zealand in 2006 to that in 2008?
Make the answer very short. 2. What is the ratio of the Savings(current US$) of Cote d'Ivoire in 2006 to that in 2009?
Your answer should be very brief. 0.29. What is the ratio of the Savings(current US$) of Cyprus in 2006 to that in 2009?
Provide a succinct answer. 1.33. What is the ratio of the Savings(current US$) in Namibia in 2006 to that in 2009?
Provide a short and direct response. 2.02. What is the ratio of the Savings(current US$) in New Zealand in 2006 to that in 2009?
Keep it short and to the point. 0.87. What is the ratio of the Savings(current US$) in Cote d'Ivoire in 2006 to that in 2010?
Your answer should be very brief. 0.33. What is the ratio of the Savings(current US$) of Cyprus in 2006 to that in 2010?
Provide a short and direct response. 1.14. What is the ratio of the Savings(current US$) in Namibia in 2006 to that in 2010?
Offer a terse response. 1.59. What is the ratio of the Savings(current US$) of New Zealand in 2006 to that in 2010?
Keep it short and to the point. 0.69. What is the ratio of the Savings(current US$) of Cote d'Ivoire in 2007 to that in 2008?
Offer a very short reply. 0.57. What is the ratio of the Savings(current US$) of Cyprus in 2007 to that in 2008?
Make the answer very short. 0.78. What is the ratio of the Savings(current US$) in New Zealand in 2007 to that in 2008?
Your answer should be very brief. 2.71. What is the ratio of the Savings(current US$) in Cote d'Ivoire in 2007 to that in 2009?
Your answer should be compact. 0.35. What is the ratio of the Savings(current US$) in Cyprus in 2007 to that in 2009?
Keep it short and to the point. 1.13. What is the ratio of the Savings(current US$) in Namibia in 2007 to that in 2009?
Keep it short and to the point. 1.58. What is the ratio of the Savings(current US$) in New Zealand in 2007 to that in 2009?
Your answer should be very brief. 1.18. What is the ratio of the Savings(current US$) of Cote d'Ivoire in 2007 to that in 2010?
Give a very brief answer. 0.4. What is the ratio of the Savings(current US$) in Cyprus in 2007 to that in 2010?
Ensure brevity in your answer.  0.97. What is the ratio of the Savings(current US$) of Namibia in 2007 to that in 2010?
Keep it short and to the point. 1.24. What is the ratio of the Savings(current US$) in New Zealand in 2007 to that in 2010?
Give a very brief answer. 0.94. What is the ratio of the Savings(current US$) of Cote d'Ivoire in 2008 to that in 2009?
Your response must be concise. 0.62. What is the ratio of the Savings(current US$) in Cyprus in 2008 to that in 2009?
Your answer should be very brief. 1.45. What is the ratio of the Savings(current US$) of Namibia in 2008 to that in 2009?
Keep it short and to the point. 1.58. What is the ratio of the Savings(current US$) in New Zealand in 2008 to that in 2009?
Your response must be concise. 0.44. What is the ratio of the Savings(current US$) of Cote d'Ivoire in 2008 to that in 2010?
Offer a terse response. 0.71. What is the ratio of the Savings(current US$) in Cyprus in 2008 to that in 2010?
Your response must be concise. 1.24. What is the ratio of the Savings(current US$) of Namibia in 2008 to that in 2010?
Your answer should be compact. 1.24. What is the ratio of the Savings(current US$) of New Zealand in 2008 to that in 2010?
Offer a very short reply. 0.35. What is the ratio of the Savings(current US$) of Cote d'Ivoire in 2009 to that in 2010?
Offer a terse response. 1.13. What is the ratio of the Savings(current US$) of Cyprus in 2009 to that in 2010?
Your response must be concise. 0.86. What is the ratio of the Savings(current US$) in Namibia in 2009 to that in 2010?
Ensure brevity in your answer.  0.78. What is the ratio of the Savings(current US$) in New Zealand in 2009 to that in 2010?
Make the answer very short. 0.8. What is the difference between the highest and the second highest Savings(current US$) of Cote d'Ivoire?
Keep it short and to the point. 4.46e+08. What is the difference between the highest and the second highest Savings(current US$) of Cyprus?
Offer a very short reply. 2.20e+08. What is the difference between the highest and the second highest Savings(current US$) of Namibia?
Make the answer very short. 5.59e+08. What is the difference between the highest and the second highest Savings(current US$) in New Zealand?
Ensure brevity in your answer.  7.63e+08. What is the difference between the highest and the lowest Savings(current US$) of Cote d'Ivoire?
Offer a very short reply. 2.66e+09. What is the difference between the highest and the lowest Savings(current US$) of Cyprus?
Offer a terse response. 8.51e+08. What is the difference between the highest and the lowest Savings(current US$) in Namibia?
Offer a very short reply. 1.29e+09. What is the difference between the highest and the lowest Savings(current US$) of New Zealand?
Offer a very short reply. 8.02e+09. 